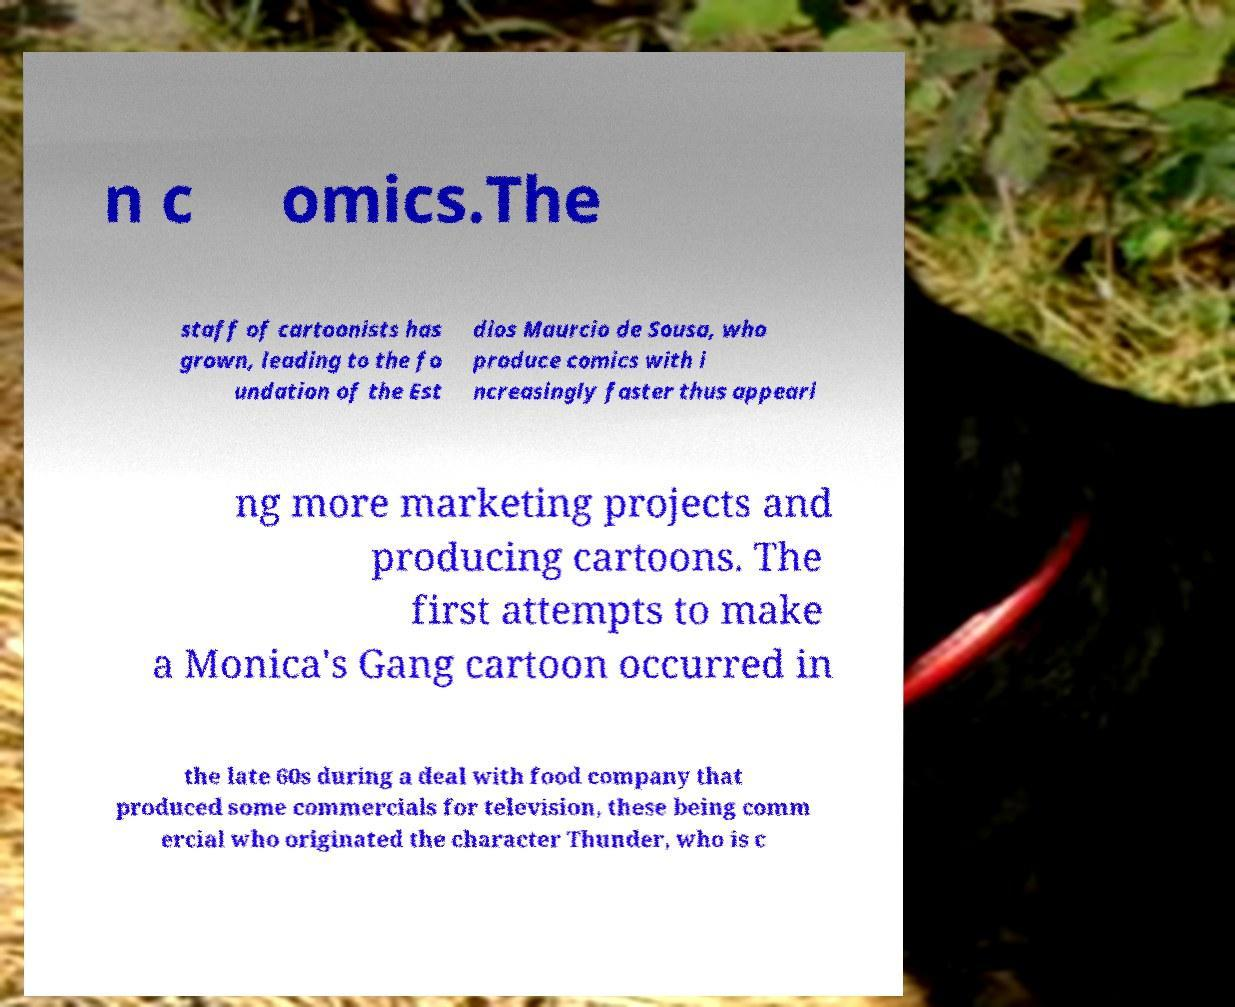Can you read and provide the text displayed in the image?This photo seems to have some interesting text. Can you extract and type it out for me? n c omics.The staff of cartoonists has grown, leading to the fo undation of the Est dios Maurcio de Sousa, who produce comics with i ncreasingly faster thus appeari ng more marketing projects and producing cartoons. The first attempts to make a Monica's Gang cartoon occurred in the late 60s during a deal with food company that produced some commercials for television, these being comm ercial who originated the character Thunder, who is c 